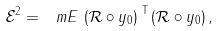Convert formula to latex. <formula><loc_0><loc_0><loc_500><loc_500>\mathcal { E } ^ { 2 } = \ m E \, \left ( \mathcal { R } \circ y _ { 0 } \right ) ^ { \text { T} } \left ( \mathcal { R } \circ y _ { 0 } \right ) ,</formula> 